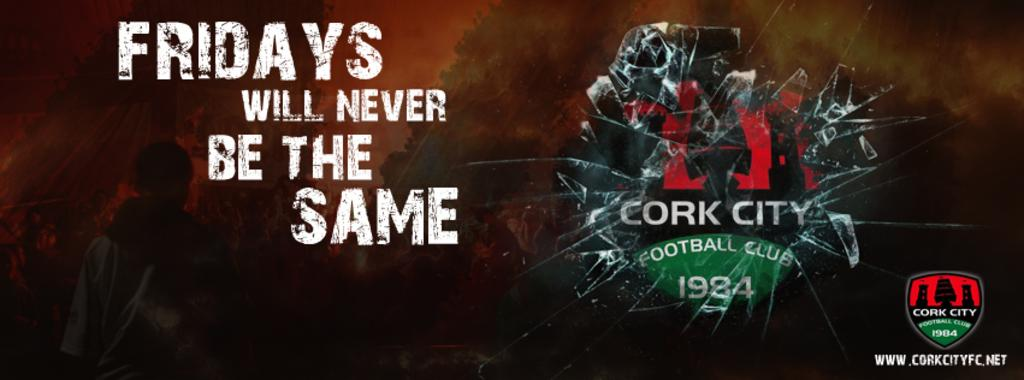<image>
Summarize the visual content of the image. Poster for Cork City Football Club on Fridays. 